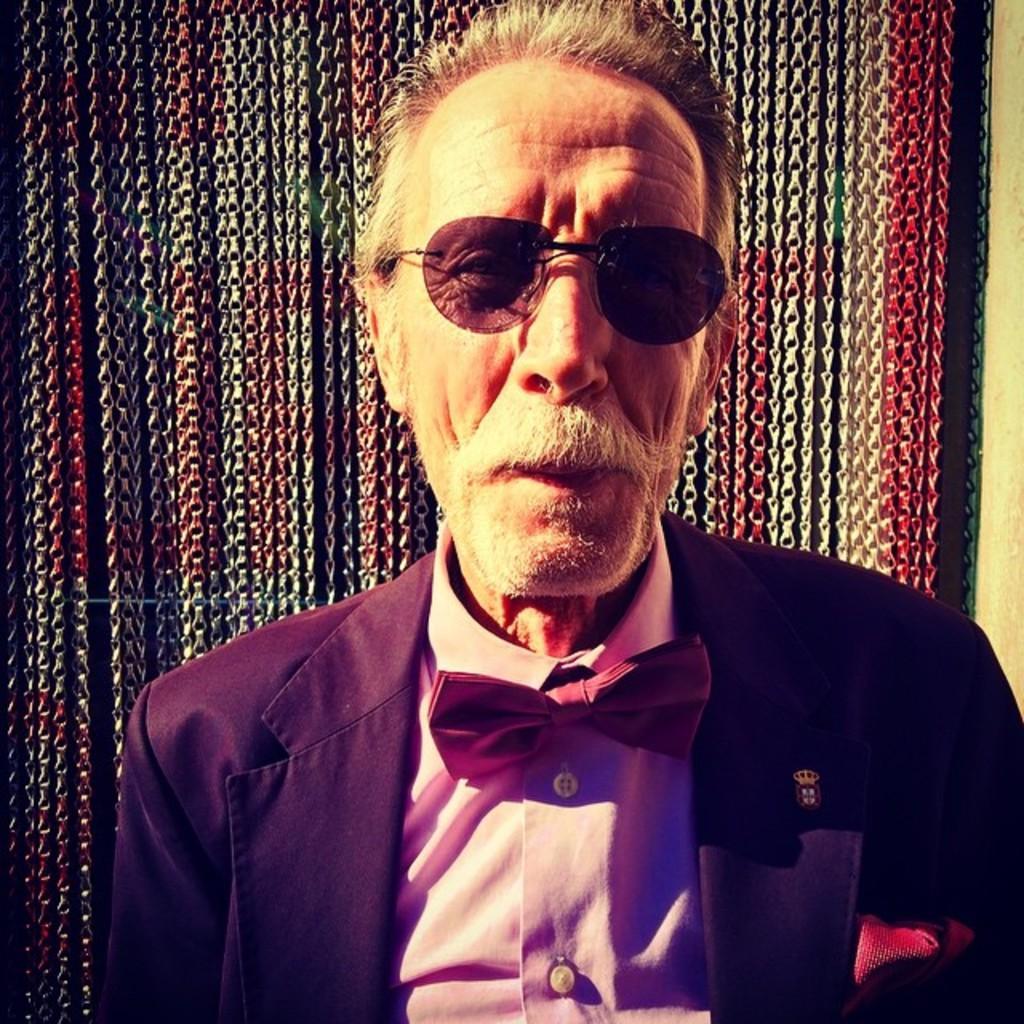How would you summarize this image in a sentence or two? In this image I can see there is a man, he has a mustache and beard, he is wearing a blazer and goggles. 